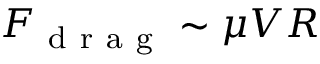Convert formula to latex. <formula><loc_0><loc_0><loc_500><loc_500>F _ { d r a g } \sim \mu V R</formula> 